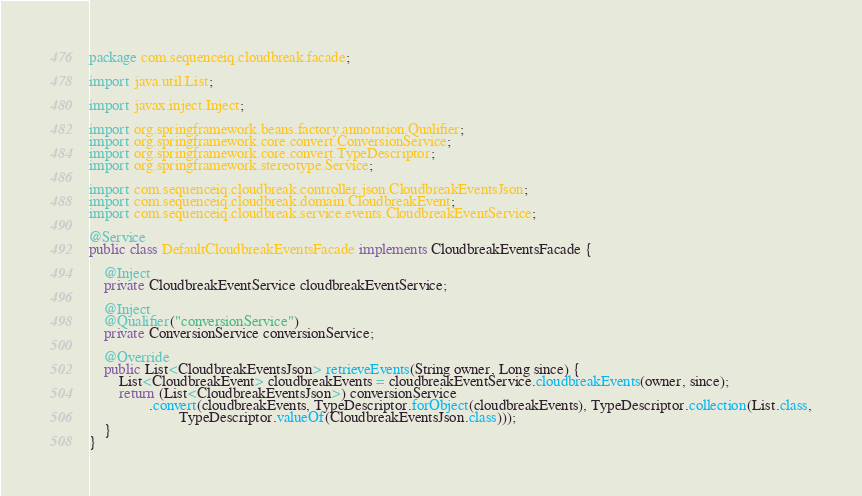Convert code to text. <code><loc_0><loc_0><loc_500><loc_500><_Java_>package com.sequenceiq.cloudbreak.facade;

import java.util.List;

import javax.inject.Inject;

import org.springframework.beans.factory.annotation.Qualifier;
import org.springframework.core.convert.ConversionService;
import org.springframework.core.convert.TypeDescriptor;
import org.springframework.stereotype.Service;

import com.sequenceiq.cloudbreak.controller.json.CloudbreakEventsJson;
import com.sequenceiq.cloudbreak.domain.CloudbreakEvent;
import com.sequenceiq.cloudbreak.service.events.CloudbreakEventService;

@Service
public class DefaultCloudbreakEventsFacade implements CloudbreakEventsFacade {

    @Inject
    private CloudbreakEventService cloudbreakEventService;

    @Inject
    @Qualifier("conversionService")
    private ConversionService conversionService;

    @Override
    public List<CloudbreakEventsJson> retrieveEvents(String owner, Long since) {
        List<CloudbreakEvent> cloudbreakEvents = cloudbreakEventService.cloudbreakEvents(owner, since);
        return (List<CloudbreakEventsJson>) conversionService
                .convert(cloudbreakEvents, TypeDescriptor.forObject(cloudbreakEvents), TypeDescriptor.collection(List.class,
                        TypeDescriptor.valueOf(CloudbreakEventsJson.class)));
    }
}
</code> 